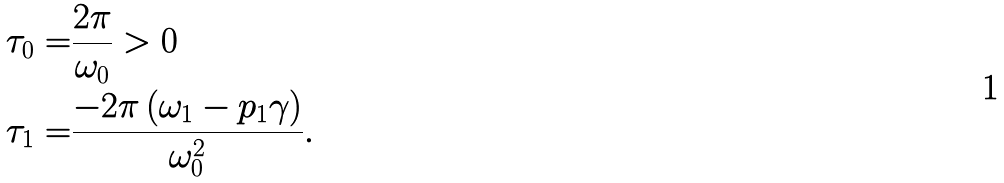<formula> <loc_0><loc_0><loc_500><loc_500>\tau _ { 0 } = & \frac { 2 \pi } { \omega _ { 0 } } > 0 \\ \tau _ { 1 } = & \frac { - 2 \pi \left ( \omega _ { 1 } - p _ { 1 } \gamma \right ) } { \omega _ { 0 } ^ { 2 } } .</formula> 